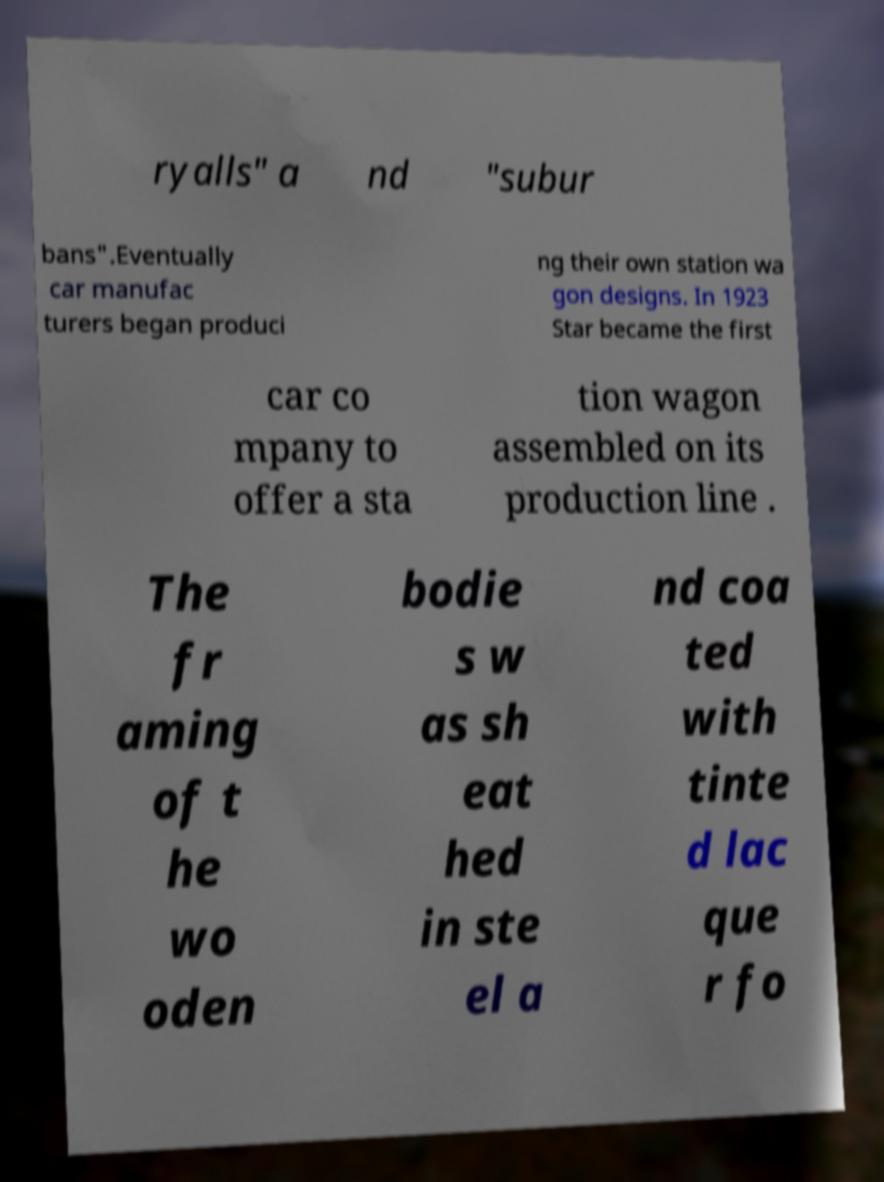Can you read and provide the text displayed in the image?This photo seems to have some interesting text. Can you extract and type it out for me? ryalls" a nd "subur bans".Eventually car manufac turers began produci ng their own station wa gon designs. In 1923 Star became the first car co mpany to offer a sta tion wagon assembled on its production line . The fr aming of t he wo oden bodie s w as sh eat hed in ste el a nd coa ted with tinte d lac que r fo 